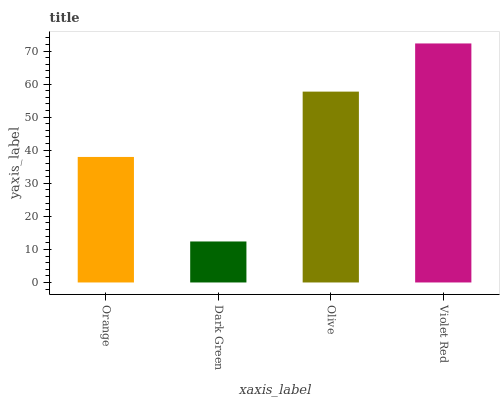Is Dark Green the minimum?
Answer yes or no. Yes. Is Violet Red the maximum?
Answer yes or no. Yes. Is Olive the minimum?
Answer yes or no. No. Is Olive the maximum?
Answer yes or no. No. Is Olive greater than Dark Green?
Answer yes or no. Yes. Is Dark Green less than Olive?
Answer yes or no. Yes. Is Dark Green greater than Olive?
Answer yes or no. No. Is Olive less than Dark Green?
Answer yes or no. No. Is Olive the high median?
Answer yes or no. Yes. Is Orange the low median?
Answer yes or no. Yes. Is Dark Green the high median?
Answer yes or no. No. Is Dark Green the low median?
Answer yes or no. No. 